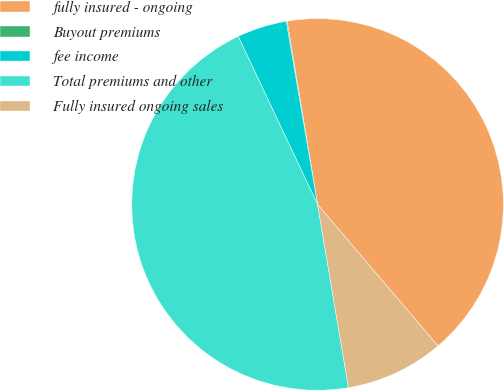Convert chart to OTSL. <chart><loc_0><loc_0><loc_500><loc_500><pie_chart><fcel>fully insured - ongoing<fcel>Buyout premiums<fcel>fee income<fcel>Total premiums and other<fcel>Fully insured ongoing sales<nl><fcel>41.4%<fcel>0.08%<fcel>4.32%<fcel>45.64%<fcel>8.56%<nl></chart> 